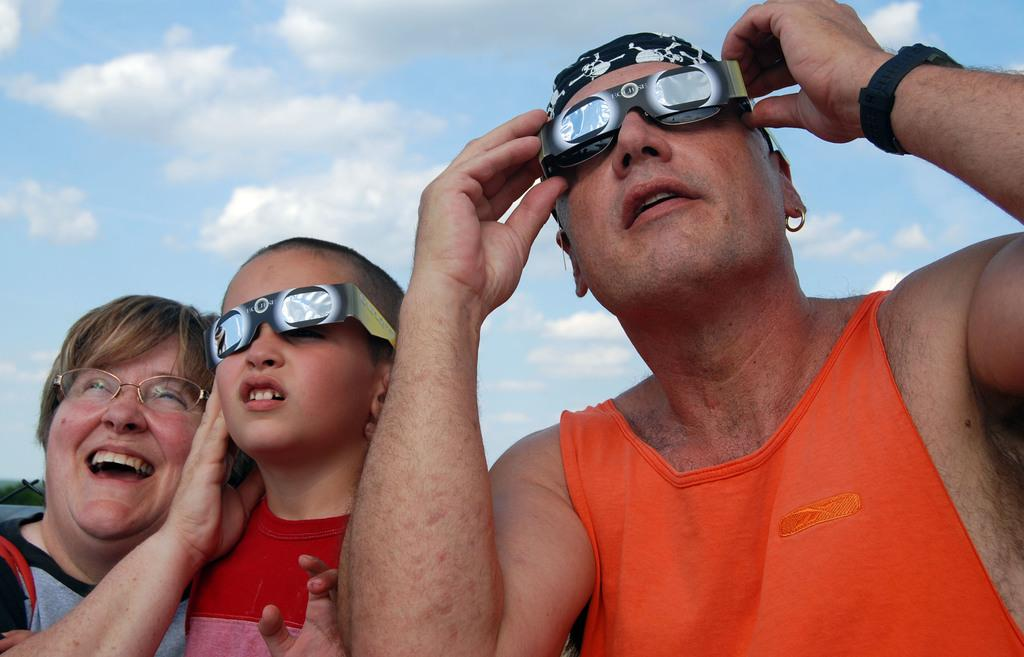What can be seen in the front of the image? There is a group of persons in the front of the image. Can you describe the facial expression of the woman on the left side of the image? The woman on the left side of the image is smiling. What is the condition of the sky in the background of the image? The sky in the background of the image is cloudy. What type of kite is being flown by the group in the image? There is no kite present in the image. What is the destination of the voyage that the group is embarking on in the image? There is no indication of a voyage in the image. What sound can be heard coming from the horn in the image? There is no horn present in the image. 